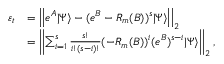<formula> <loc_0><loc_0><loc_500><loc_500>\begin{array} { r l } { \varepsilon _ { t } } & { = \left | \left | e ^ { A } | \Psi \rangle - ( e ^ { B } - R _ { m } ( B ) ) ^ { s } | \Psi \rangle \right | \right | _ { 2 } } \\ & { = \left | \left | \sum _ { i = 1 } ^ { s } \frac { s ! } { i ! ( s - i ) ! } ( - R _ { m } ( B ) ) ^ { i } ( e ^ { B } ) ^ { s - i } | \Psi \rangle \right | \right | _ { 2 } , } \end{array}</formula> 